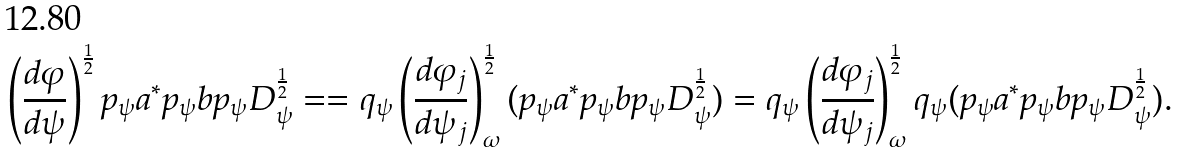<formula> <loc_0><loc_0><loc_500><loc_500>\left ( \frac { d \varphi } { d \psi } \right ) ^ { \frac { 1 } { 2 } } p _ { \psi } a ^ { \ast } p _ { \psi } b p _ { \psi } D _ { \psi } ^ { \frac { 1 } { 2 } } = = q _ { \psi } \left ( \frac { d \varphi _ { j } } { d \psi _ { j } } \right ) _ { \omega } ^ { \frac { 1 } { 2 } } ( p _ { \psi } a ^ { \ast } p _ { \psi } b p _ { \psi } D _ { \psi } ^ { \frac { 1 } { 2 } } ) = q _ { \psi } \left ( \frac { d \varphi _ { j } } { d \psi _ { j } } \right ) _ { \omega } ^ { \frac { 1 } { 2 } } q _ { \psi } ( p _ { \psi } a ^ { \ast } p _ { \psi } b p _ { \psi } D _ { \psi } ^ { \frac { 1 } { 2 } } ) .</formula> 